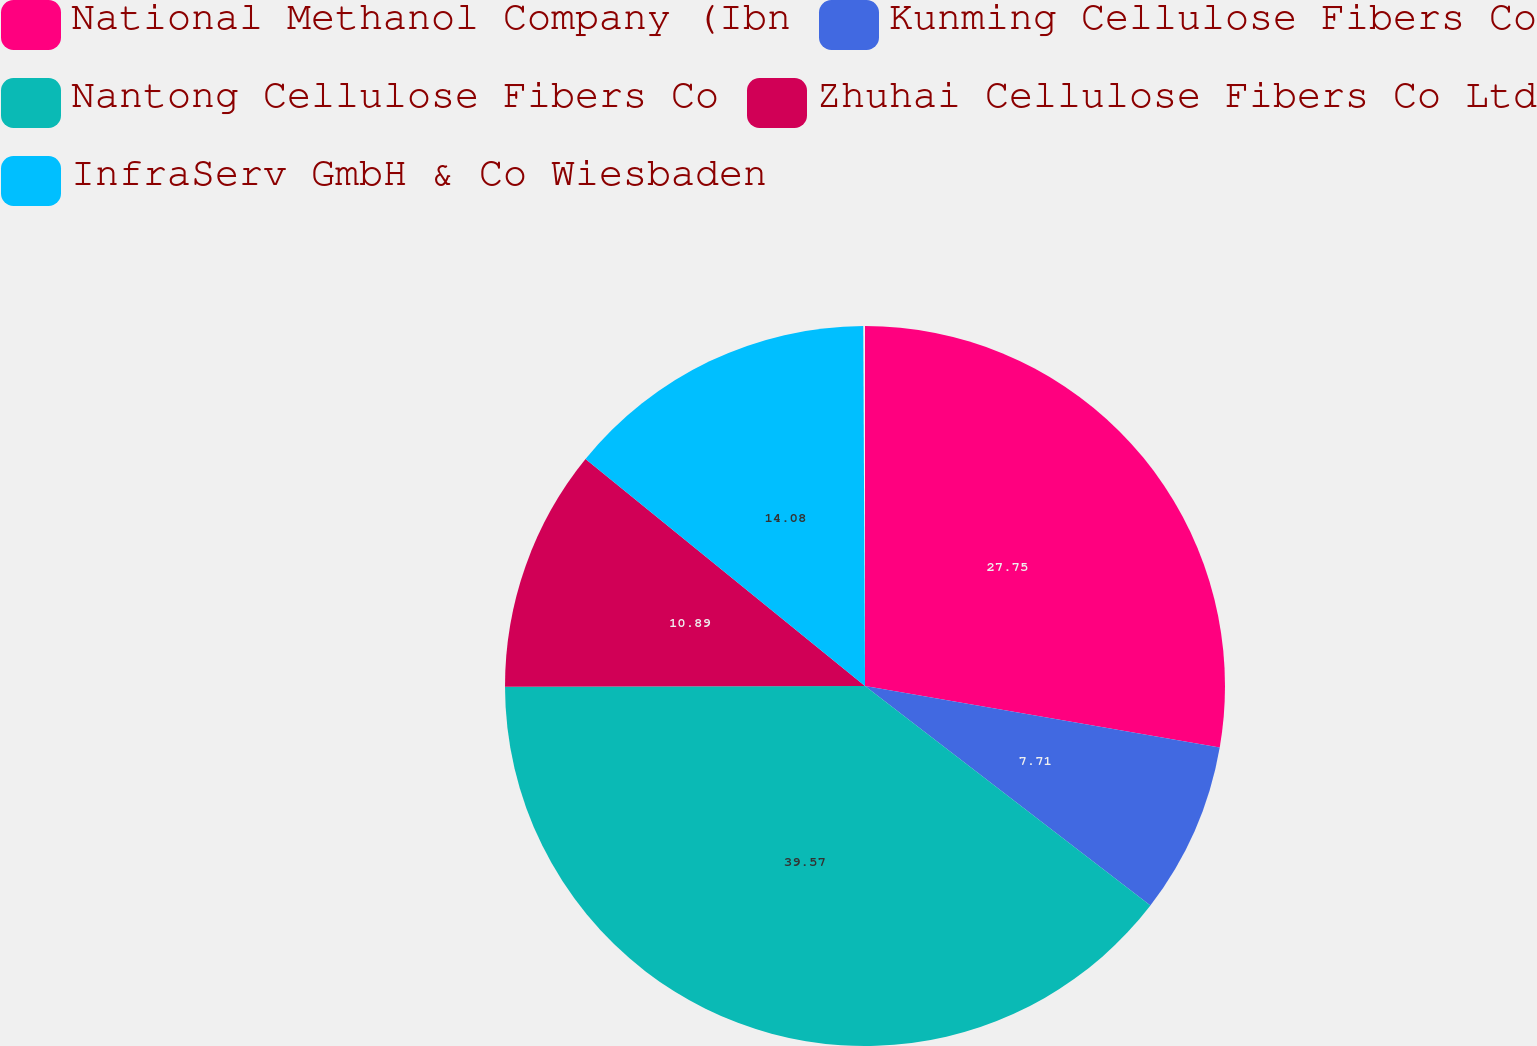<chart> <loc_0><loc_0><loc_500><loc_500><pie_chart><fcel>National Methanol Company (Ibn<fcel>Kunming Cellulose Fibers Co<fcel>Nantong Cellulose Fibers Co<fcel>Zhuhai Cellulose Fibers Co Ltd<fcel>InfraServ GmbH & Co Wiesbaden<nl><fcel>27.75%<fcel>7.71%<fcel>39.57%<fcel>10.89%<fcel>14.08%<nl></chart> 